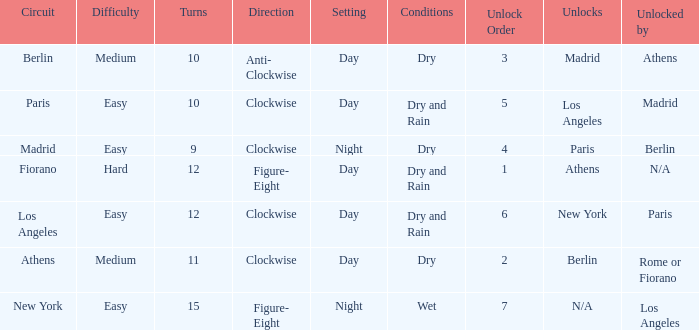What is the lowest unlock order for the athens circuit? 2.0. 